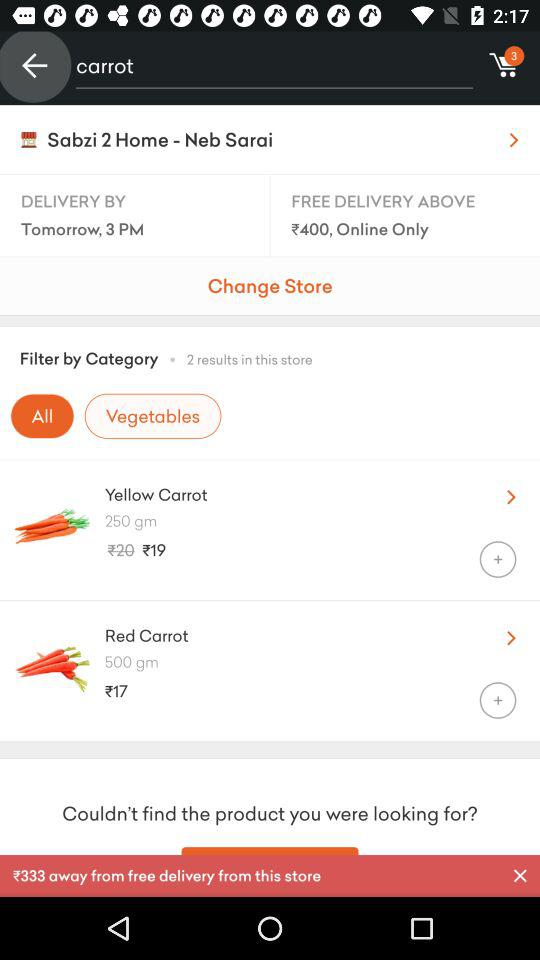How many items are in my cart?
Answer the question using a single word or phrase. 3 